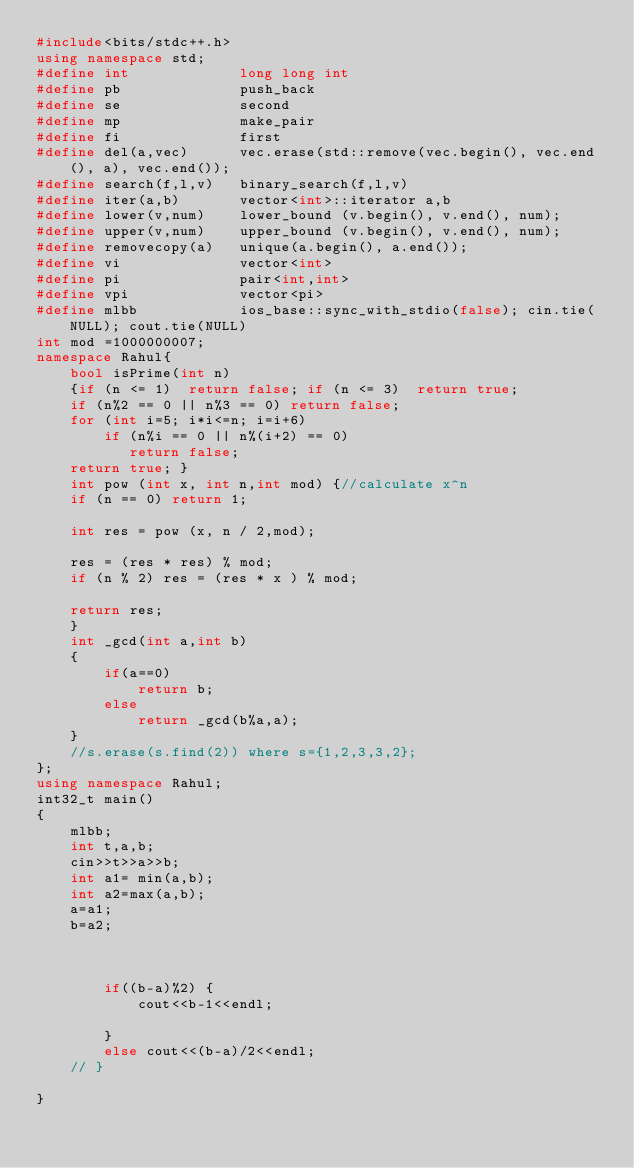Convert code to text. <code><loc_0><loc_0><loc_500><loc_500><_C++_>#include<bits/stdc++.h>
using namespace std;
#define int             long long int
#define pb              push_back
#define se              second
#define mp              make_pair
#define fi              first
#define del(a,vec)      vec.erase(std::remove(vec.begin(), vec.end(), a), vec.end());
#define search(f,l,v)   binary_search(f,l,v)
#define iter(a,b)       vector<int>::iterator a,b
#define lower(v,num)    lower_bound (v.begin(), v.end(), num);
#define upper(v,num)    upper_bound (v.begin(), v.end(), num); 
#define removecopy(a)   unique(a.begin(), a.end()); 
#define vi              vector<int> 
#define pi              pair<int,int>    
#define vpi             vector<pi>      
#define mlbb            ios_base::sync_with_stdio(false); cin.tie(NULL); cout.tie(NULL)    
int mod =1000000007;
namespace Rahul{
    bool isPrime(int n) 
    {if (n <= 1)  return false; if (n <= 3)  return true; 
    if (n%2 == 0 || n%3 == 0) return false; 
    for (int i=5; i*i<=n; i=i+6) 
        if (n%i == 0 || n%(i+2) == 0) 
           return false; 
    return true; }
    int pow (int x, int n,int mod) {//calculate x^n
    if (n == 0) return 1;

    int res = pow (x, n / 2,mod);

    res = (res * res) % mod;
    if (n % 2) res = (res * x ) % mod;

    return res;
    }
    int _gcd(int a,int b)
    {
        if(a==0)
            return b;
        else    
            return _gcd(b%a,a);
    }
    //s.erase(s.find(2)) where s={1,2,3,3,2}; 
};
using namespace Rahul;
int32_t main()
{
    mlbb;
    int t,a,b;
    cin>>t>>a>>b;
    int a1= min(a,b);
    int a2=max(a,b);
    a=a1;
    b=a2;
    
    
   
        if((b-a)%2) {
            cout<<b-1<<endl;
            
        }
        else cout<<(b-a)/2<<endl;
    // }
    
}
</code> 